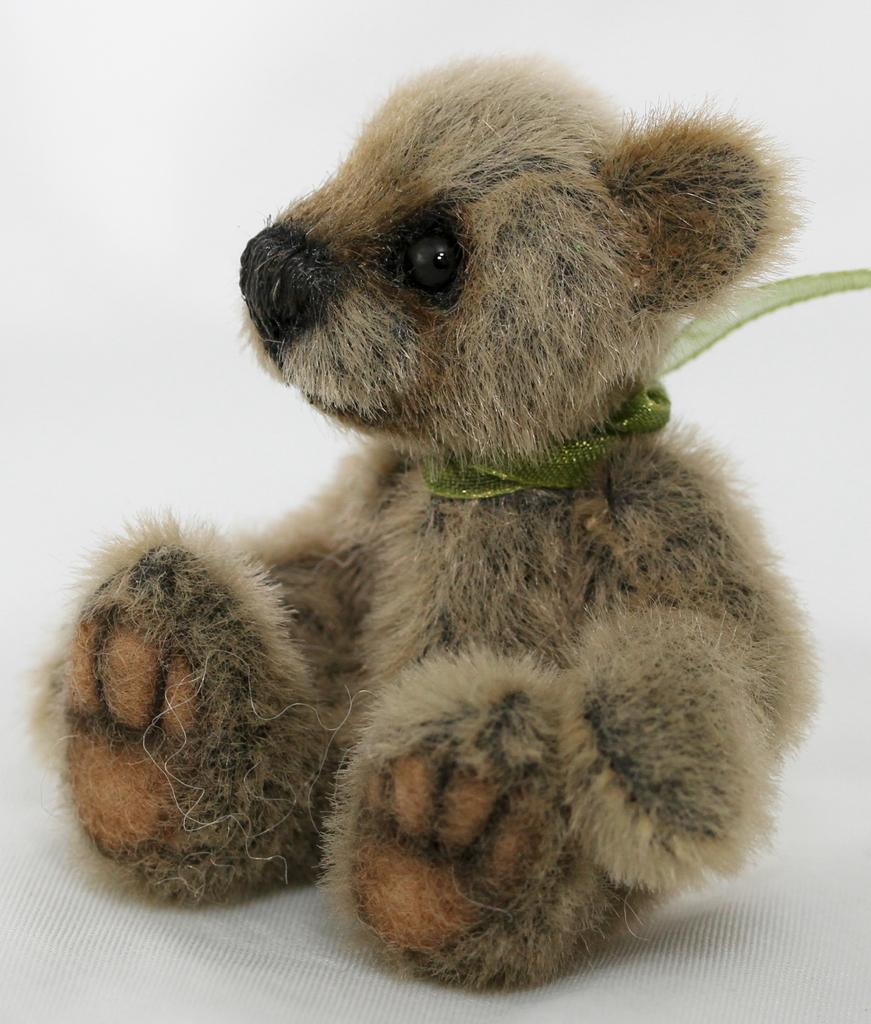What type of toy is present in the image? There is a small teddy bear in the image. What color is the teddy bear? The teddy bear is light brown in color. What is the color of the background in the image? The background of the image is white. What type of bone is visible in the image? There is no bone present in the image; it features a small teddy bear on a white background. What subject is the teddy bear teaching in the image? There is no indication in the image that the teddy bear is teaching any subject. 